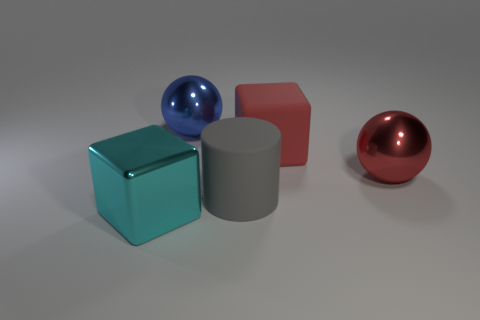How big is the object that is in front of the big red rubber object and on the right side of the big gray thing?
Provide a short and direct response. Large. How many cyan blocks are the same size as the red cube?
Provide a short and direct response. 1. What material is the other large object that is the same shape as the cyan thing?
Give a very brief answer. Rubber. Does the big red rubber thing have the same shape as the red shiny object?
Give a very brief answer. No. How many large metal balls are on the right side of the red matte thing?
Offer a very short reply. 1. There is a big red object that is in front of the block that is behind the large shiny cube; what shape is it?
Make the answer very short. Sphere. What shape is the big object that is made of the same material as the cylinder?
Provide a short and direct response. Cube. There is a cube behind the big cyan block; does it have the same size as the cube in front of the big red ball?
Ensure brevity in your answer.  Yes. The matte thing that is right of the gray rubber object has what shape?
Provide a short and direct response. Cube. The big rubber cylinder has what color?
Ensure brevity in your answer.  Gray. 